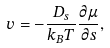<formula> <loc_0><loc_0><loc_500><loc_500>v = - \frac { D _ { s } } { k _ { B } T } \frac { \partial \mu } { \partial s } ,</formula> 